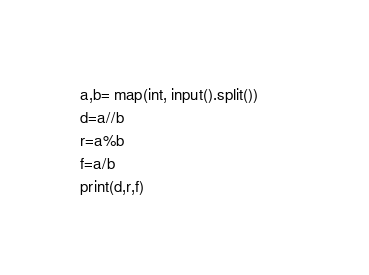<code> <loc_0><loc_0><loc_500><loc_500><_Python_>a,b= map(int, input().split())       
d=a//b
r=a%b
f=a/b
print(d,r,f)</code> 